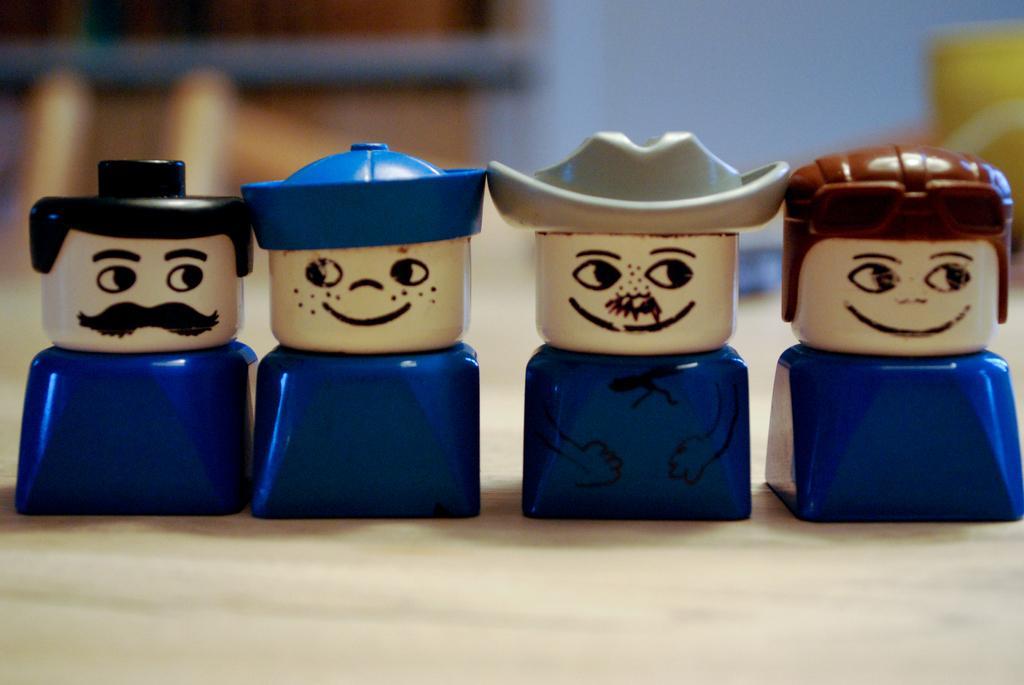Please provide a concise description of this image. In this picture, we see the four toys or the figurines in blue color. We see the caps in black, blue, grey and brown color. At the bottom, we see the floor. In the background, it is in brown, blue and yellow color. This picture is blurred in the background. 